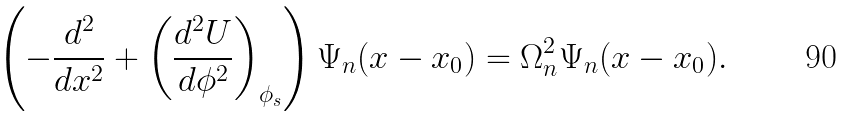Convert formula to latex. <formula><loc_0><loc_0><loc_500><loc_500>\left ( - \frac { d ^ { 2 } } { d x ^ { 2 } } + \left ( \frac { d ^ { 2 } U } { d \phi ^ { 2 } } \right ) _ { \phi _ { s } } \right ) \Psi _ { n } ( x - x _ { 0 } ) = \Omega ^ { 2 } _ { n } \Psi _ { n } ( x - x _ { 0 } ) .</formula> 